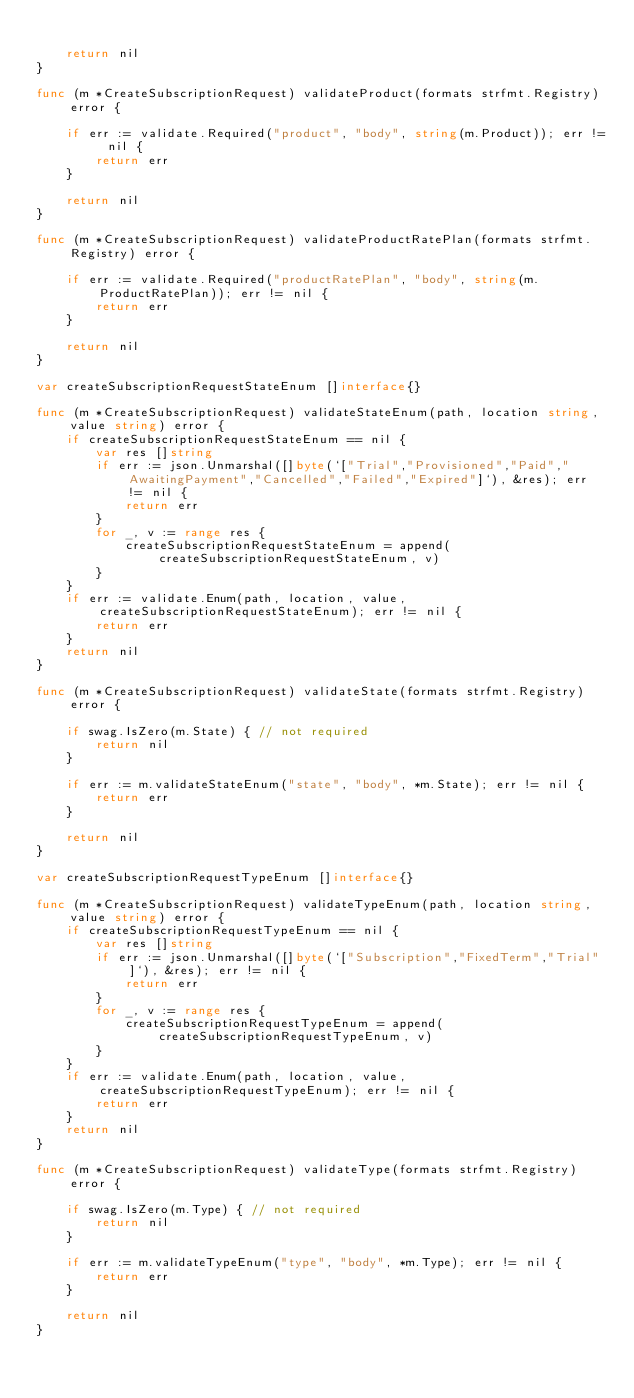<code> <loc_0><loc_0><loc_500><loc_500><_Go_>
	return nil
}

func (m *CreateSubscriptionRequest) validateProduct(formats strfmt.Registry) error {

	if err := validate.Required("product", "body", string(m.Product)); err != nil {
		return err
	}

	return nil
}

func (m *CreateSubscriptionRequest) validateProductRatePlan(formats strfmt.Registry) error {

	if err := validate.Required("productRatePlan", "body", string(m.ProductRatePlan)); err != nil {
		return err
	}

	return nil
}

var createSubscriptionRequestStateEnum []interface{}

func (m *CreateSubscriptionRequest) validateStateEnum(path, location string, value string) error {
	if createSubscriptionRequestStateEnum == nil {
		var res []string
		if err := json.Unmarshal([]byte(`["Trial","Provisioned","Paid","AwaitingPayment","Cancelled","Failed","Expired"]`), &res); err != nil {
			return err
		}
		for _, v := range res {
			createSubscriptionRequestStateEnum = append(createSubscriptionRequestStateEnum, v)
		}
	}
	if err := validate.Enum(path, location, value, createSubscriptionRequestStateEnum); err != nil {
		return err
	}
	return nil
}

func (m *CreateSubscriptionRequest) validateState(formats strfmt.Registry) error {

	if swag.IsZero(m.State) { // not required
		return nil
	}

	if err := m.validateStateEnum("state", "body", *m.State); err != nil {
		return err
	}

	return nil
}

var createSubscriptionRequestTypeEnum []interface{}

func (m *CreateSubscriptionRequest) validateTypeEnum(path, location string, value string) error {
	if createSubscriptionRequestTypeEnum == nil {
		var res []string
		if err := json.Unmarshal([]byte(`["Subscription","FixedTerm","Trial"]`), &res); err != nil {
			return err
		}
		for _, v := range res {
			createSubscriptionRequestTypeEnum = append(createSubscriptionRequestTypeEnum, v)
		}
	}
	if err := validate.Enum(path, location, value, createSubscriptionRequestTypeEnum); err != nil {
		return err
	}
	return nil
}

func (m *CreateSubscriptionRequest) validateType(formats strfmt.Registry) error {

	if swag.IsZero(m.Type) { // not required
		return nil
	}

	if err := m.validateTypeEnum("type", "body", *m.Type); err != nil {
		return err
	}

	return nil
}
</code> 